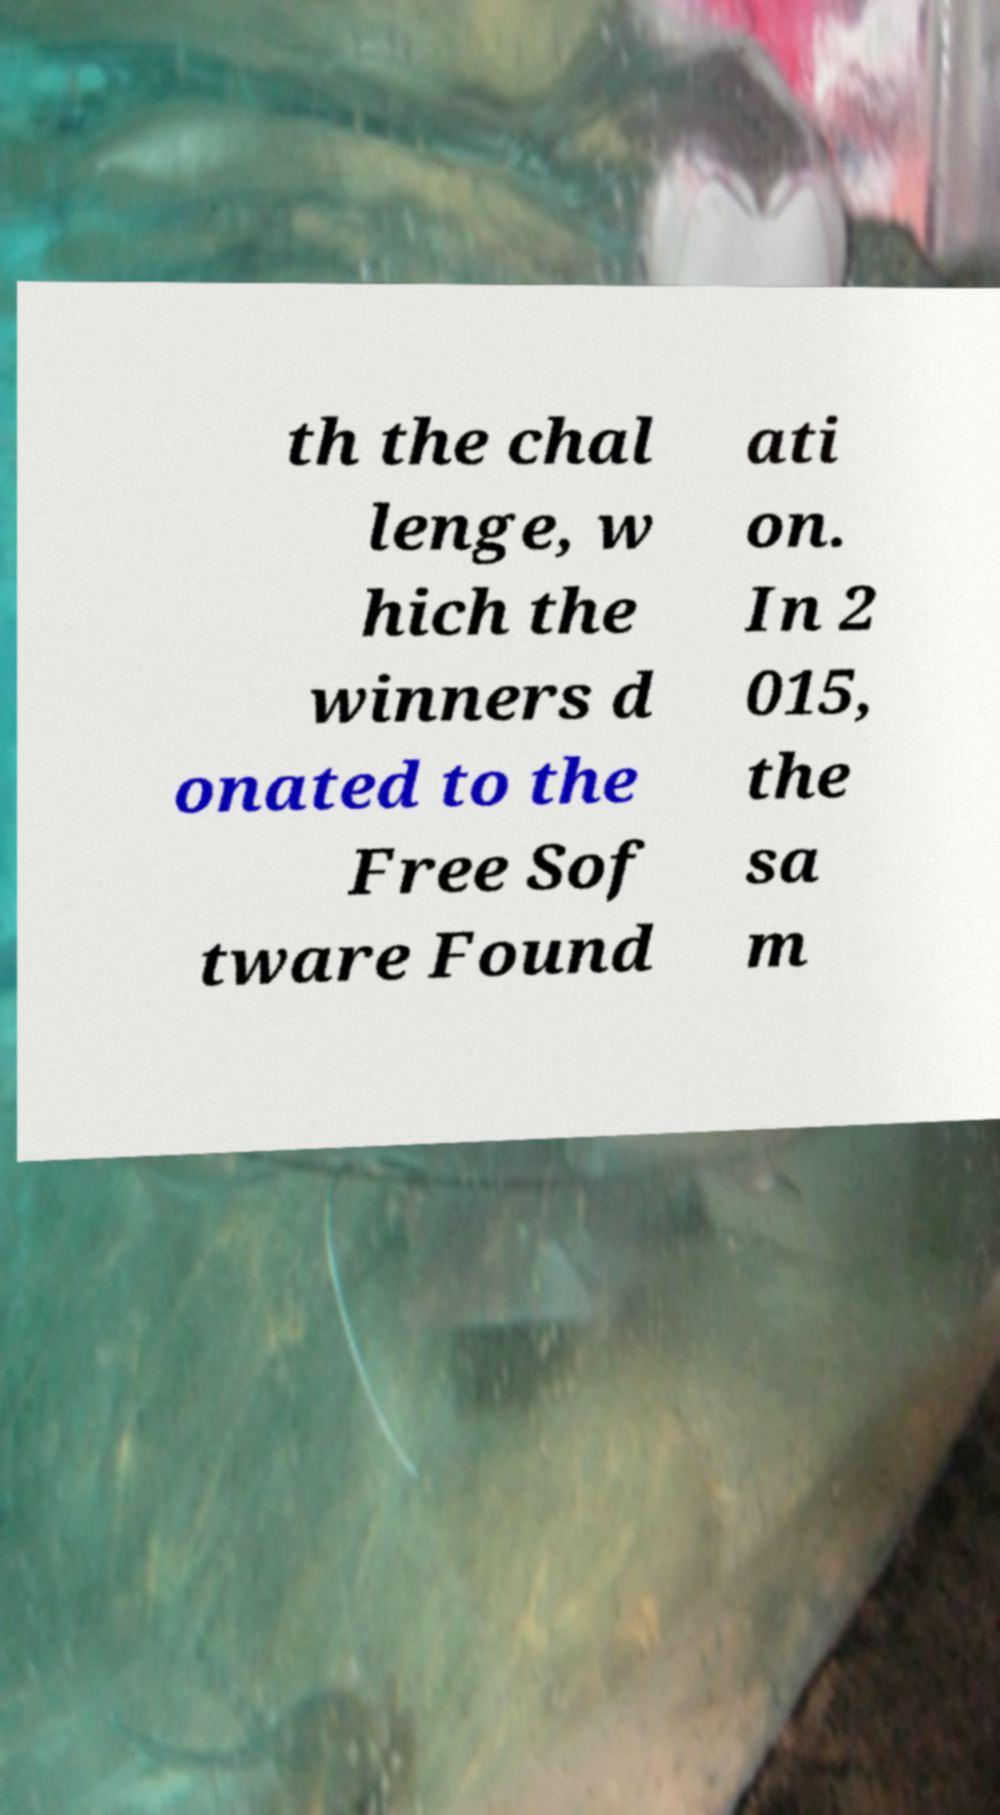Please identify and transcribe the text found in this image. th the chal lenge, w hich the winners d onated to the Free Sof tware Found ati on. In 2 015, the sa m 